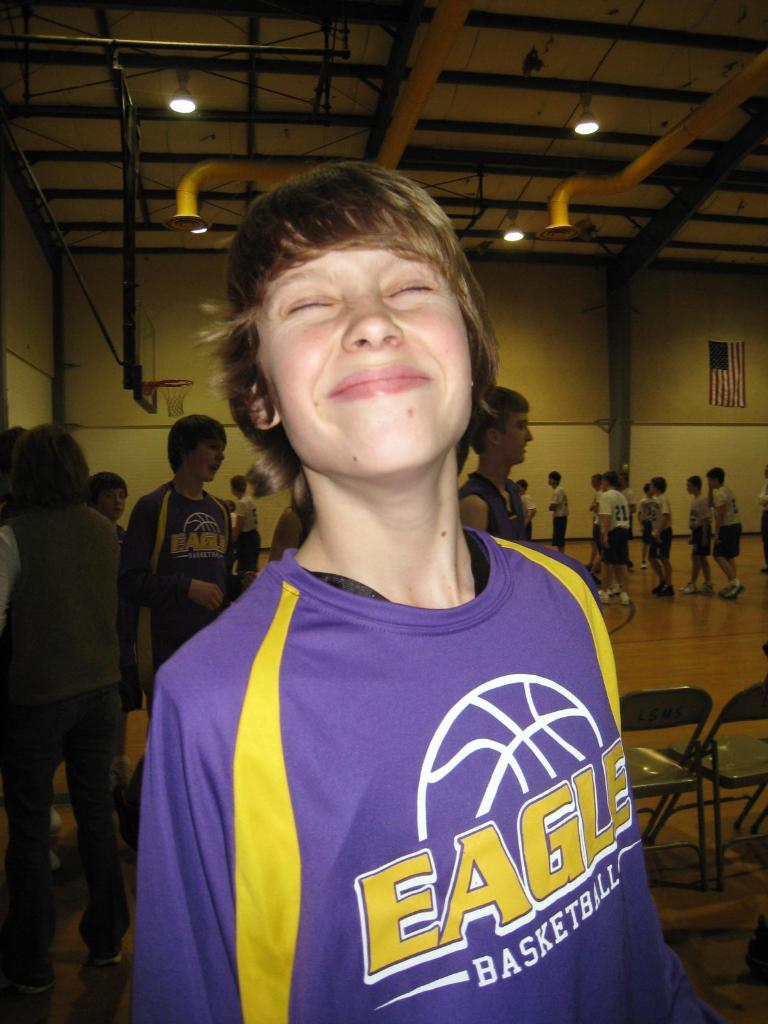<image>
Describe the image concisely. A boy is wearing an Eagle basketball shirt. 